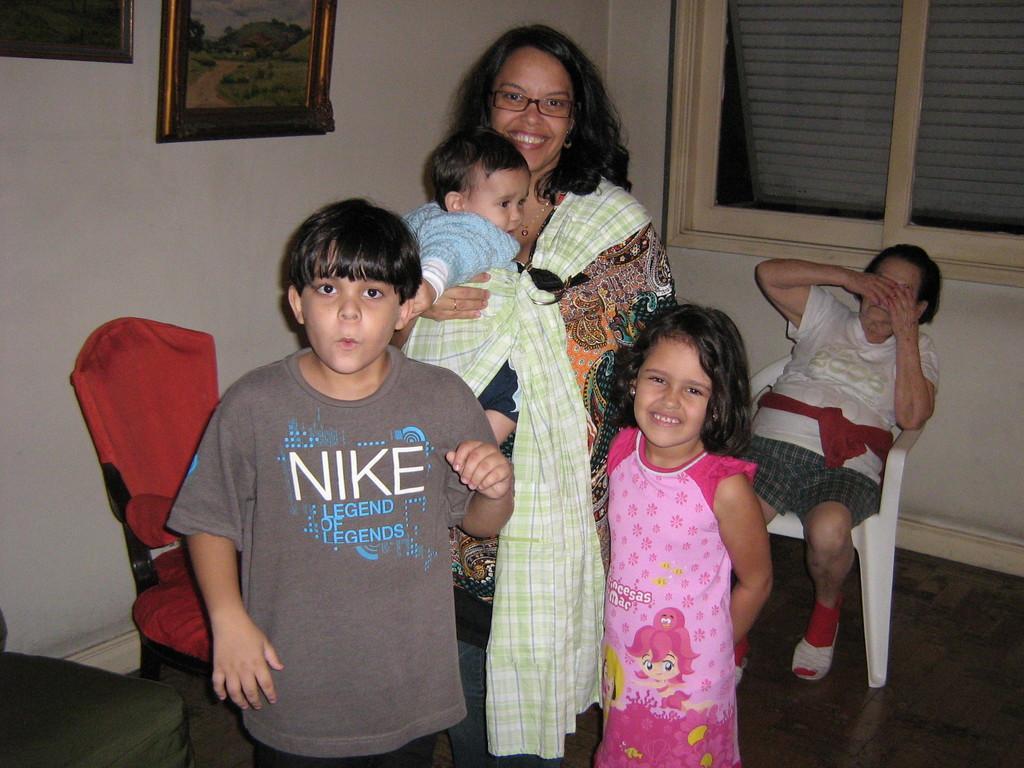Can you describe this image briefly? In this image we can see people. In the background of the image there is a wall, chairs, frame, windows and other objects. On the left side of the image there is an object. 